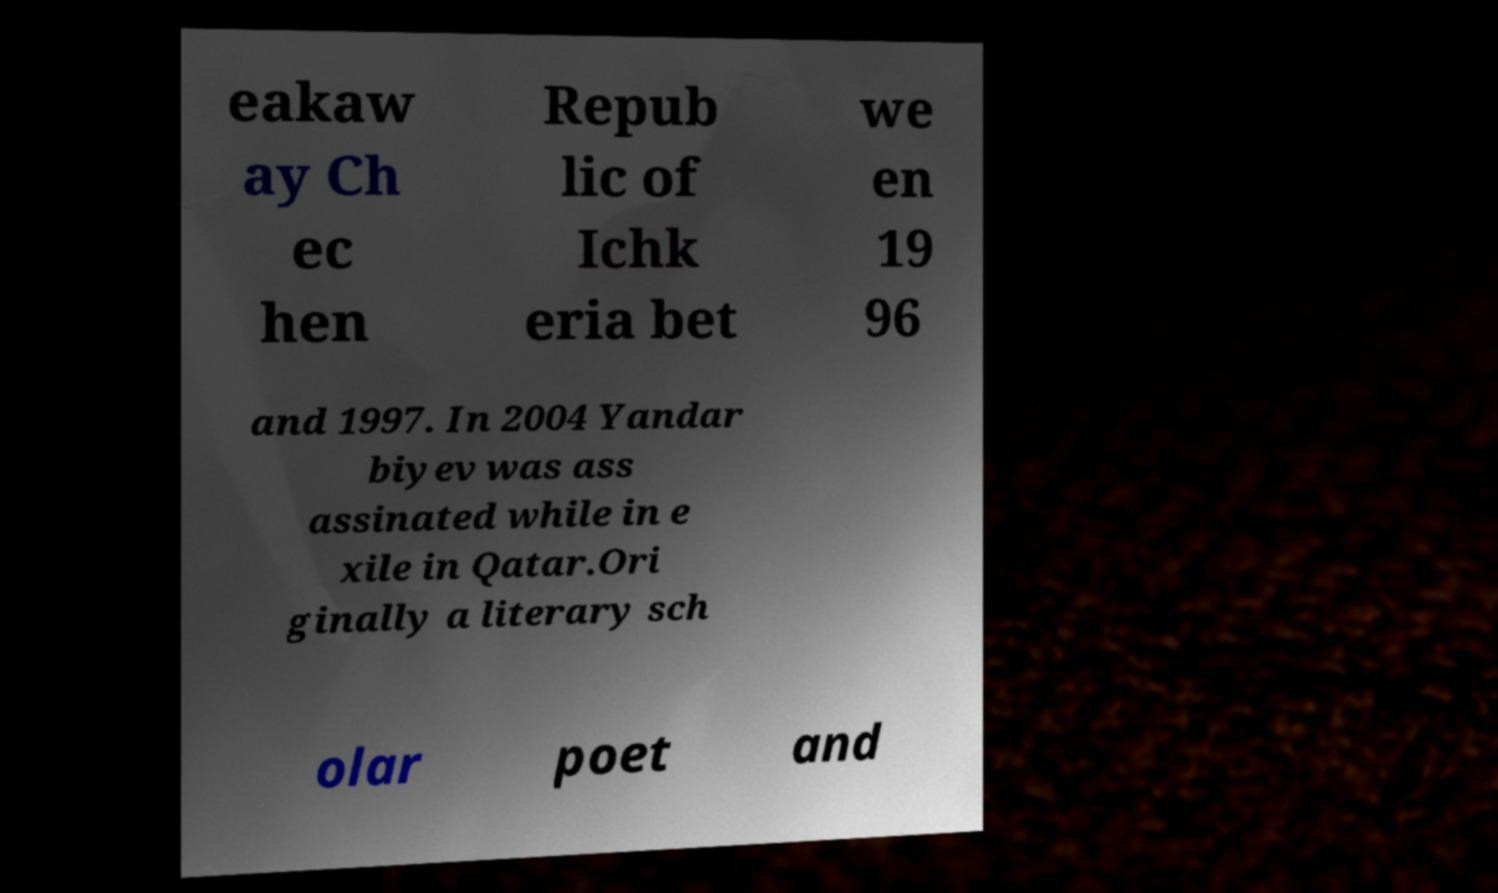Please identify and transcribe the text found in this image. eakaw ay Ch ec hen Repub lic of Ichk eria bet we en 19 96 and 1997. In 2004 Yandar biyev was ass assinated while in e xile in Qatar.Ori ginally a literary sch olar poet and 